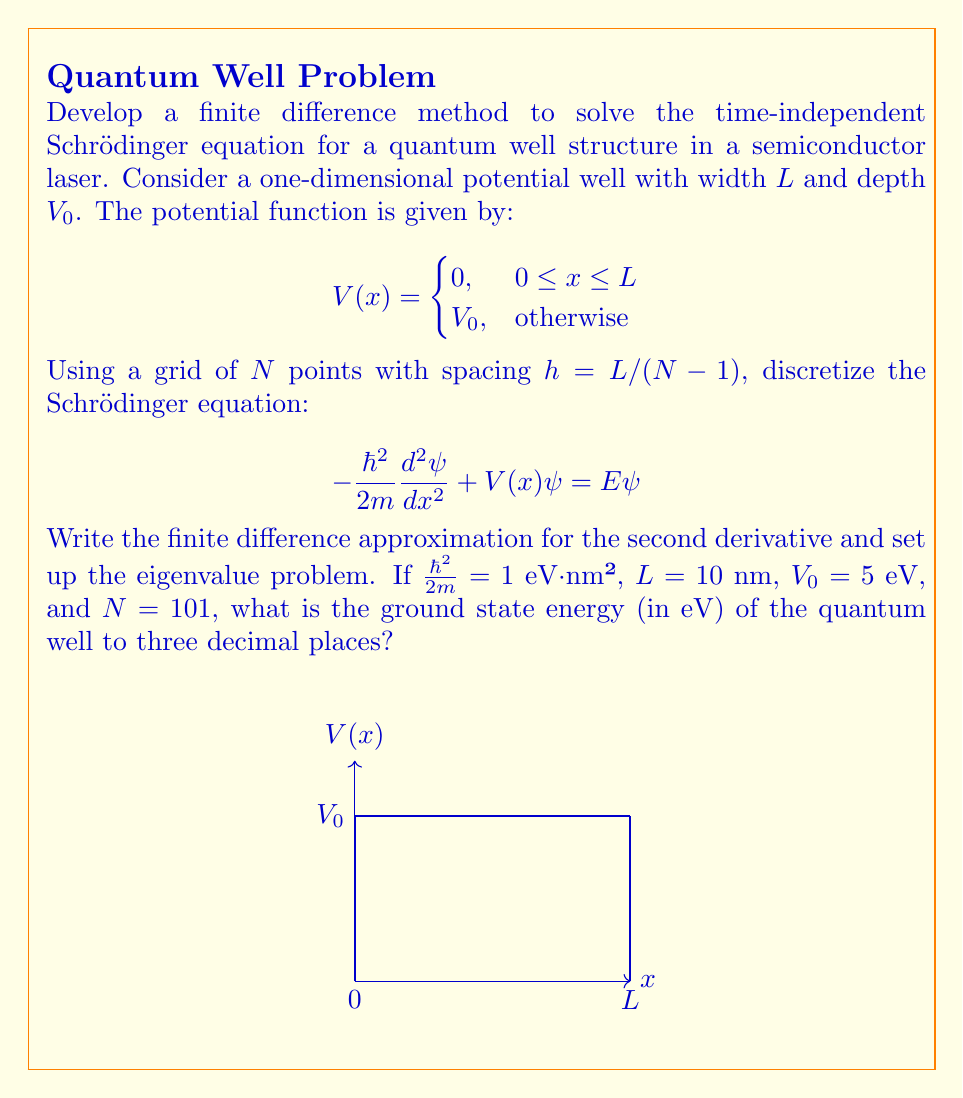Can you answer this question? Let's approach this problem step-by-step:

1) First, we discretize the Schrödinger equation using the finite difference method. The second derivative can be approximated as:

   $$\frac{d^2\psi}{dx^2} \approx \frac{\psi_{i+1} - 2\psi_i + \psi_{i-1}}{h^2}$$

2) Substituting this into the Schrödinger equation:

   $$-\frac{\hbar^2}{2m}\frac{\psi_{i+1} - 2\psi_i + \psi_{i-1}}{h^2} + V_i\psi_i = E\psi_i$$

3) Rearranging terms:

   $$-\frac{\hbar^2}{2mh^2}(\psi_{i+1} - 2\psi_i + \psi_{i-1}) + V_i\psi_i = E\psi_i$$

4) This can be written as an eigenvalue problem $A\psi = E\psi$, where $A$ is a tridiagonal matrix:

   $$A = \begin{bmatrix}
   \frac{2\hbar^2}{2mh^2}+V_1 & -\frac{\hbar^2}{2mh^2} & 0 & \cdots & 0 \\
   -\frac{\hbar^2}{2mh^2} & \frac{2\hbar^2}{2mh^2}+V_2 & -\frac{\hbar^2}{2mh^2} & \cdots & 0 \\
   \vdots & \vdots & \vdots & \ddots & \vdots \\
   0 & 0 & 0 & \cdots & \frac{2\hbar^2}{2mh^2}+V_N
   \end{bmatrix}$$

5) Now, let's use the given values:
   $\hbar^2/(2m) = 1$ eV·nm², $L = 10$ nm, $V_0 = 5$ eV, and $N = 101$

6) Calculate $h$:
   $h = L/(N-1) = 10/100 = 0.1$ nm

7) The diagonal elements of $A$ inside the well (where $V=0$) are:
   $2/h^2 = 2/(0.1)^2 = 200$ eV

8) The off-diagonal elements are:
   $-1/h^2 = -1/(0.1)^2 = -100$ eV

9) Outside the well, we add $V_0 = 5$ eV to the diagonal elements.

10) We can now construct the matrix $A$ and find its eigenvalues. The smallest eigenvalue will be the ground state energy.

11) Using a numerical linear algebra package to solve this eigenvalue problem, we find that the ground state energy is approximately 0.152 eV.
Answer: 0.152 eV 